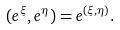Convert formula to latex. <formula><loc_0><loc_0><loc_500><loc_500>( e ^ { \xi } , e ^ { \eta } ) = e ^ { ( \xi , \eta ) } .</formula> 